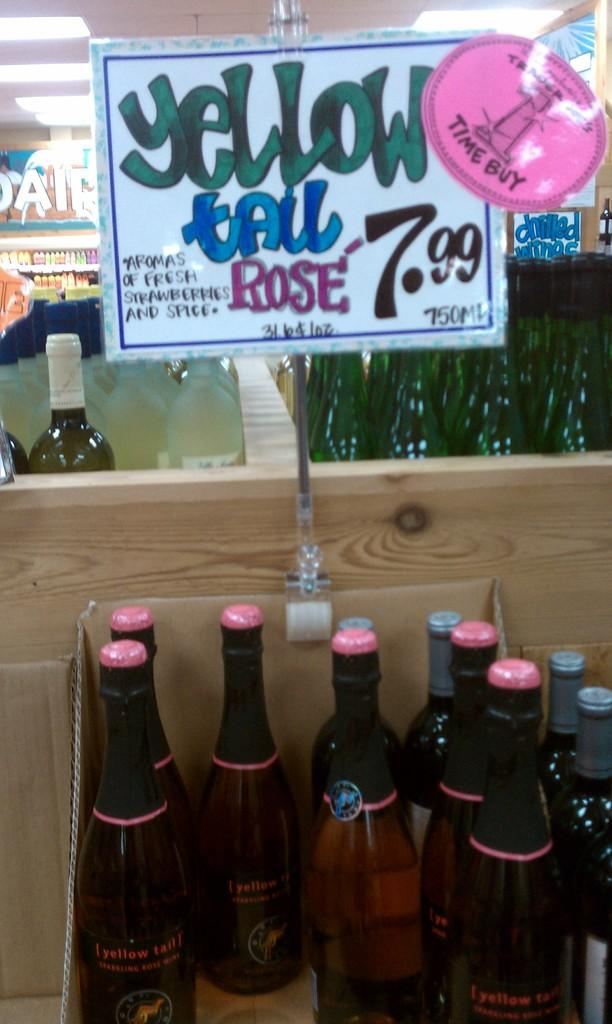Provide a one-sentence caption for the provided image. A sign positioned above a wine bottle display that read "Yellow Tail Rose 7.99". 